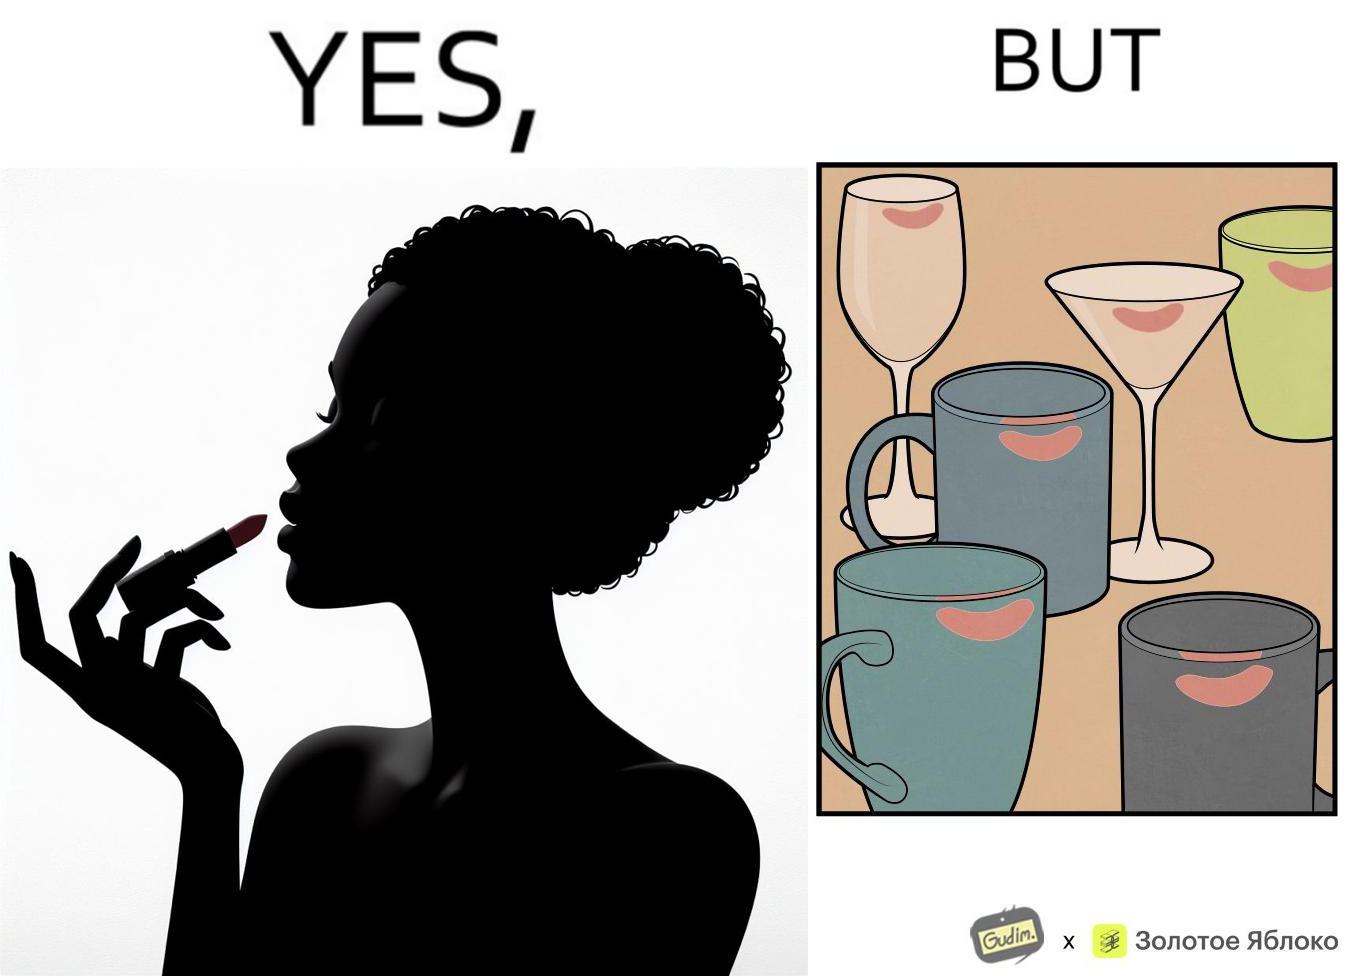Explain the humor or irony in this image. The image is ironic, because the left image suggest that a person applies lipsticks on their lips to make their lips look attractive or to keep them hydrated but on the contrary it gets sticked to the glasses or mugs and gets wasted 